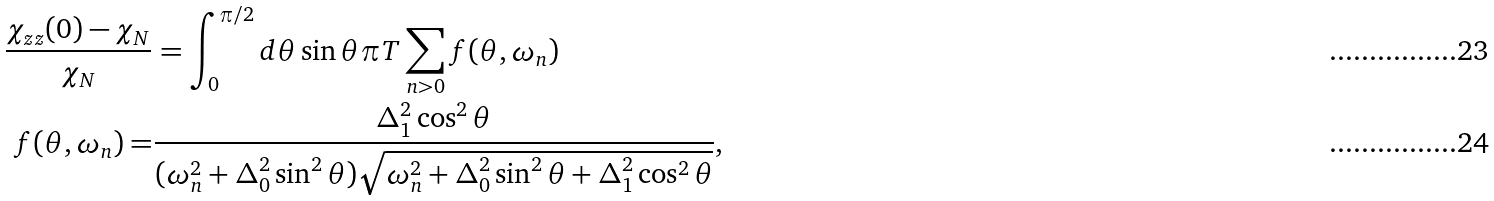<formula> <loc_0><loc_0><loc_500><loc_500>\frac { \chi _ { z z } ( 0 ) - \chi _ { N } } { \chi _ { N } } & = \int _ { 0 } ^ { \pi / 2 } d \theta \sin \theta \pi T \sum _ { n > 0 } f ( \theta , \omega _ { n } ) \\ f ( \theta , \omega _ { n } ) = & \frac { \Delta _ { 1 } ^ { 2 } \cos ^ { 2 } \theta } { ( \omega _ { n } ^ { 2 } + \Delta _ { 0 } ^ { 2 } \sin ^ { 2 } \theta ) \sqrt { \omega _ { n } ^ { 2 } + \Delta _ { 0 } ^ { 2 } \sin ^ { 2 } \theta + \Delta _ { 1 } ^ { 2 } \cos ^ { 2 } \theta } } ,</formula> 